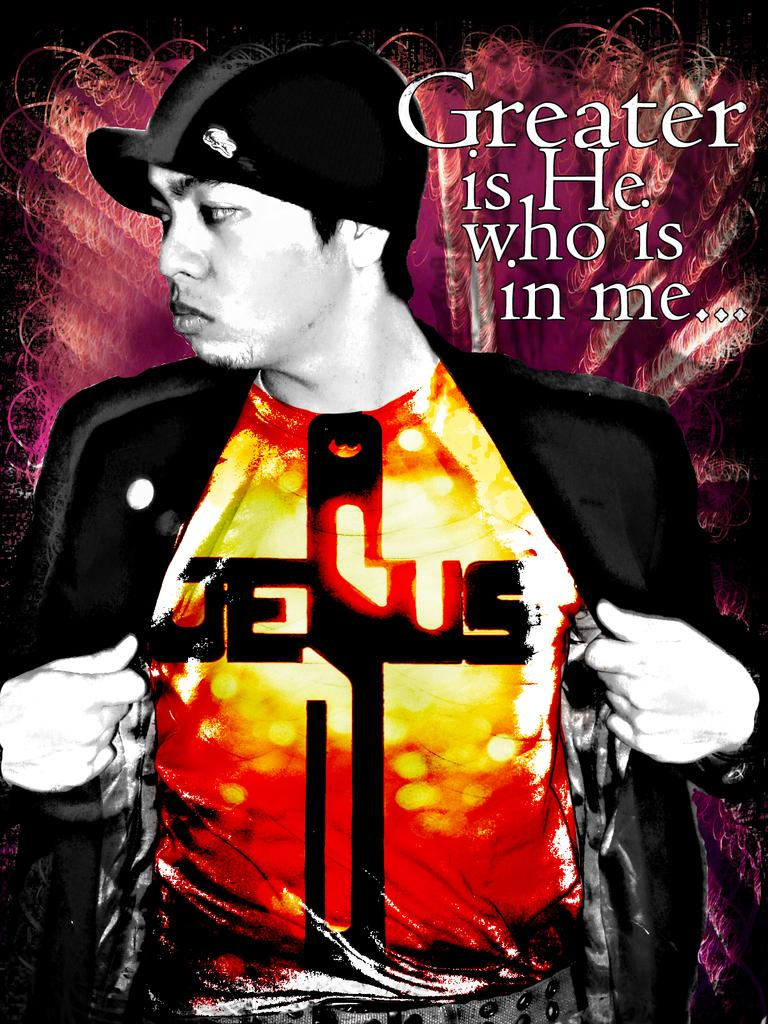<image>
Create a compact narrative representing the image presented. Someone wears a Jesus shirt and has a quote above them. 